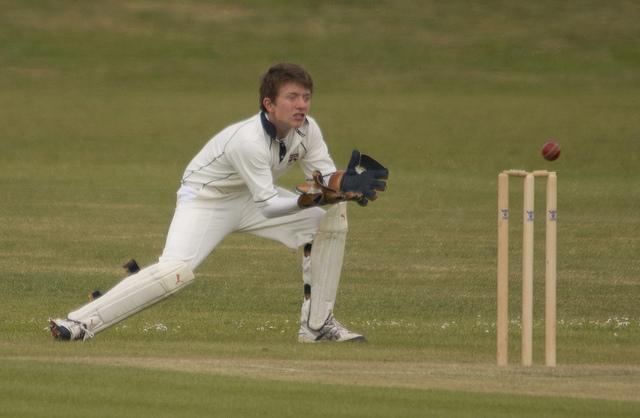How many of this man's feet are flat on the ground?
Give a very brief answer. 1. 